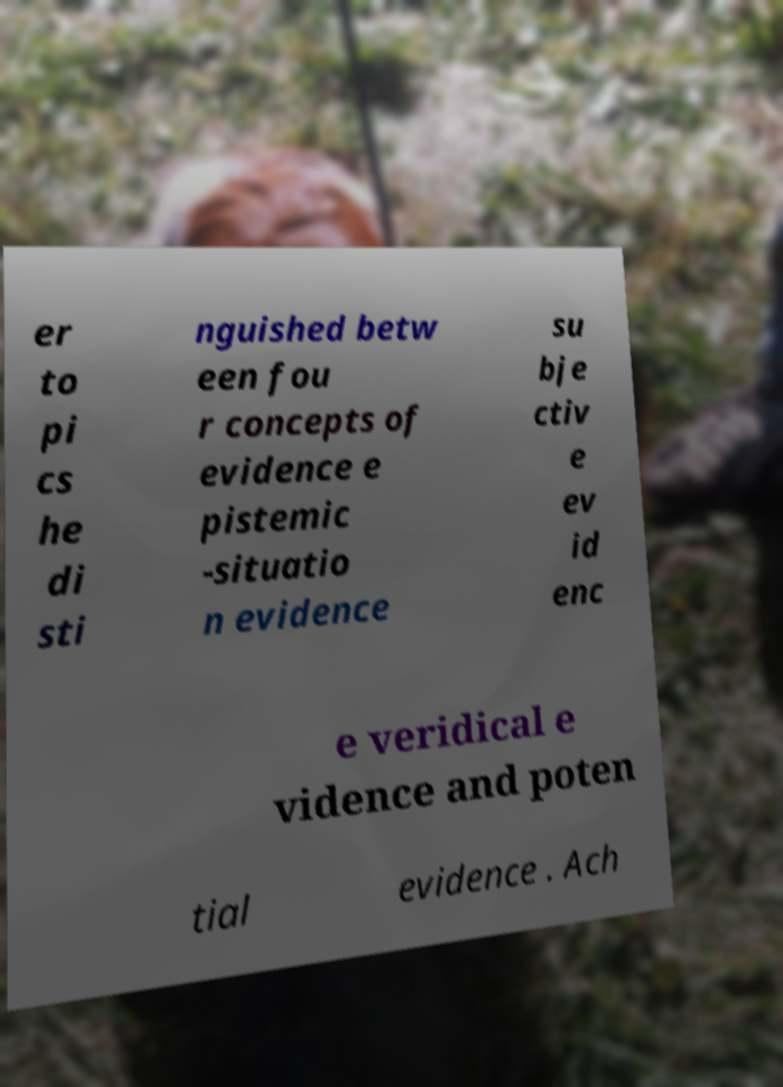Please read and relay the text visible in this image. What does it say? er to pi cs he di sti nguished betw een fou r concepts of evidence e pistemic -situatio n evidence su bje ctiv e ev id enc e veridical e vidence and poten tial evidence . Ach 